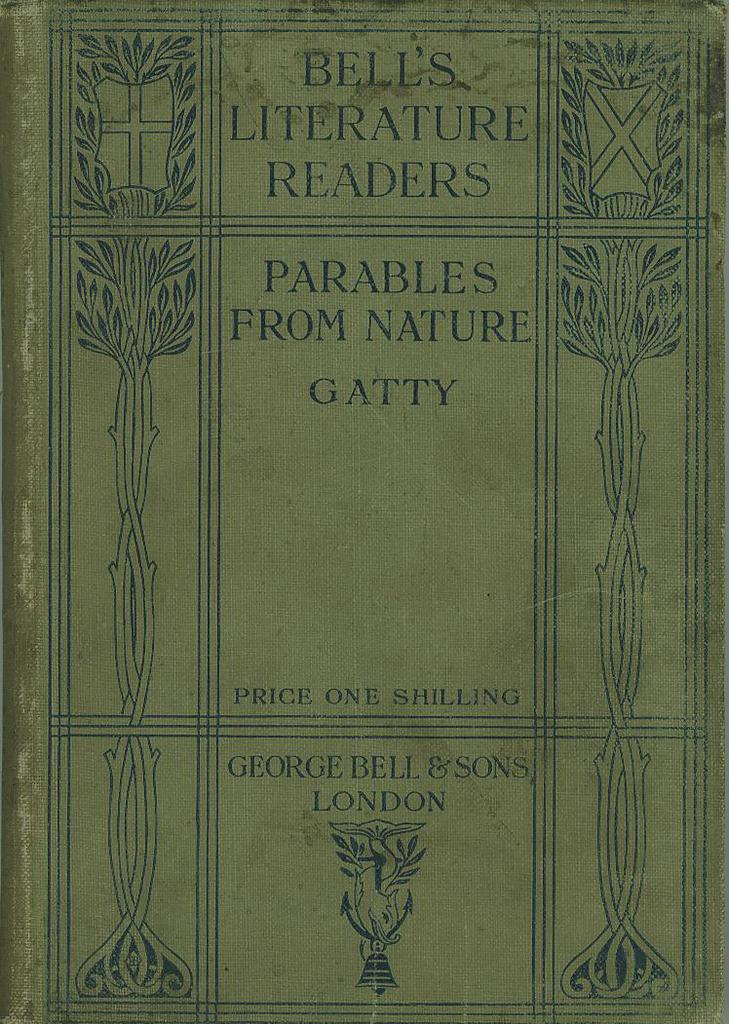<image>
Share a concise interpretation of the image provided. cover of the book titled parables from nature by gatty. 